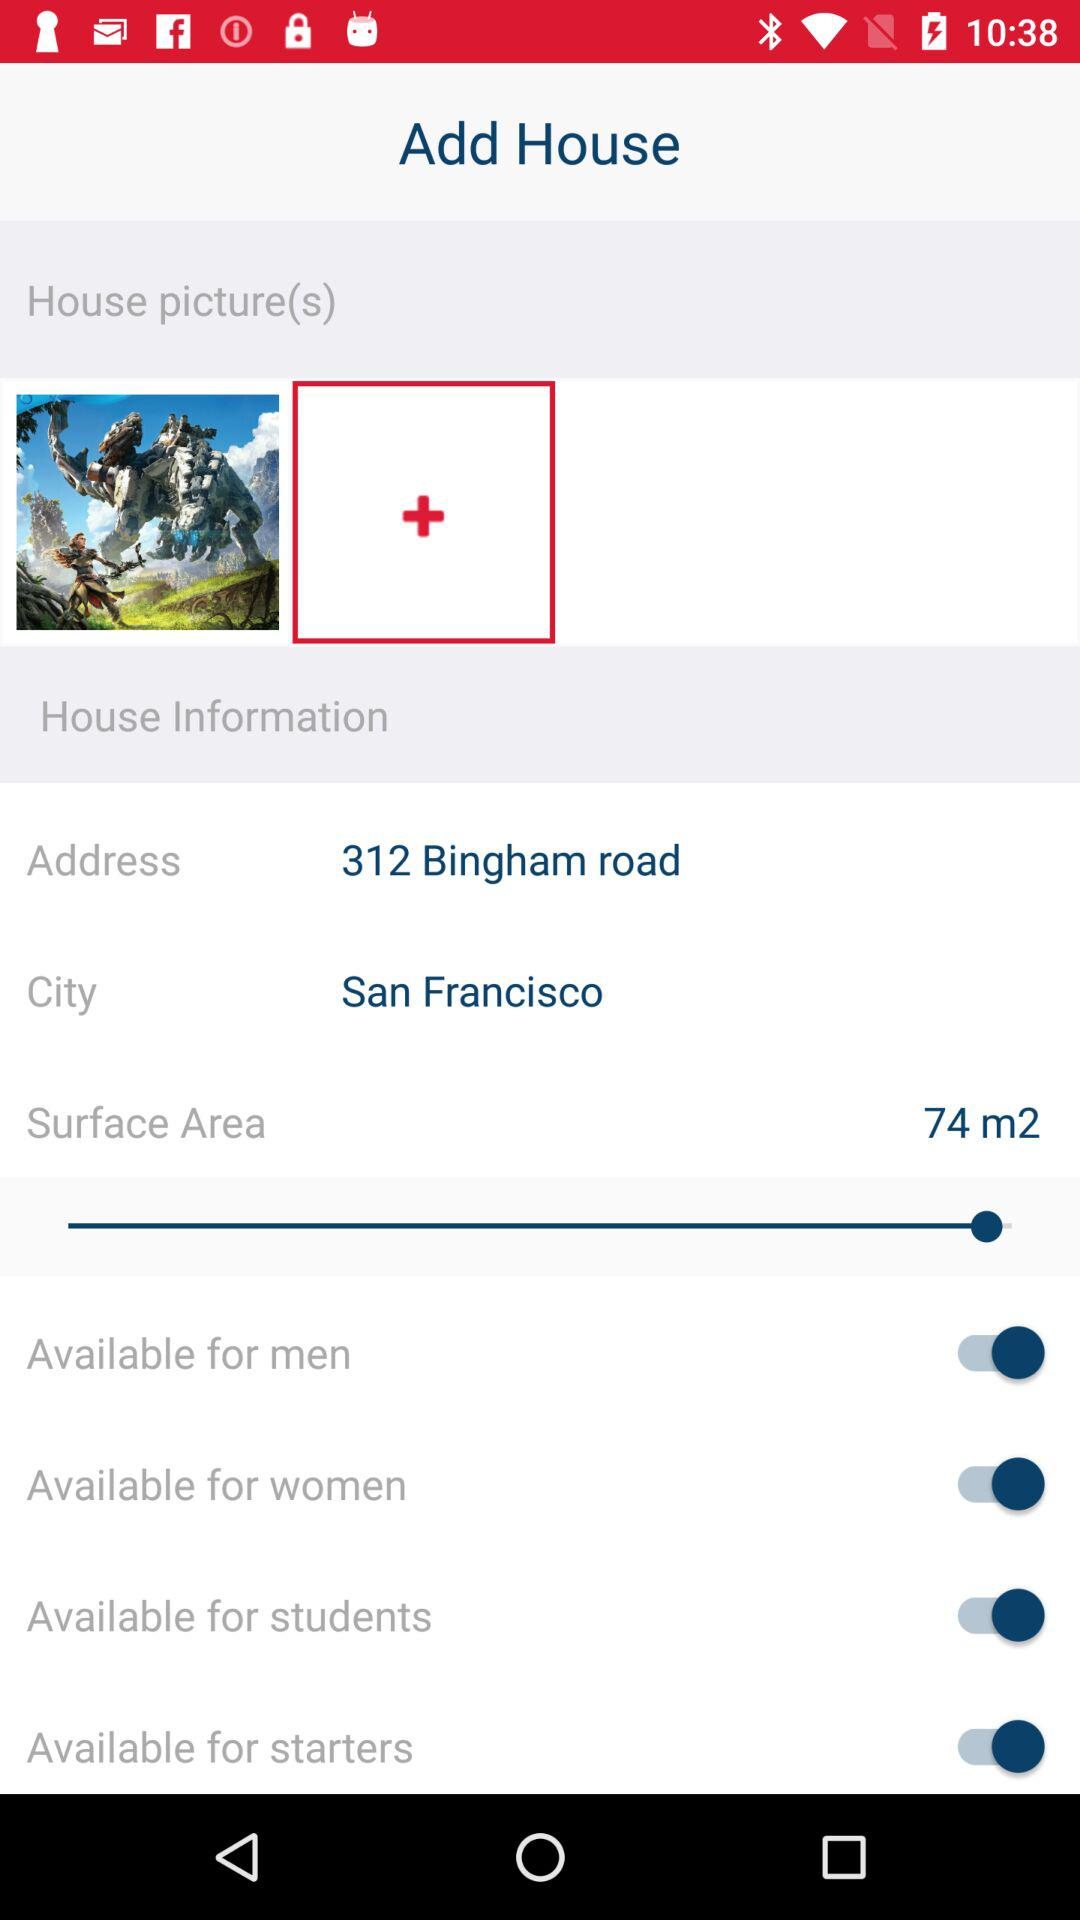What is the status of "Available for women"? The status is "on". 